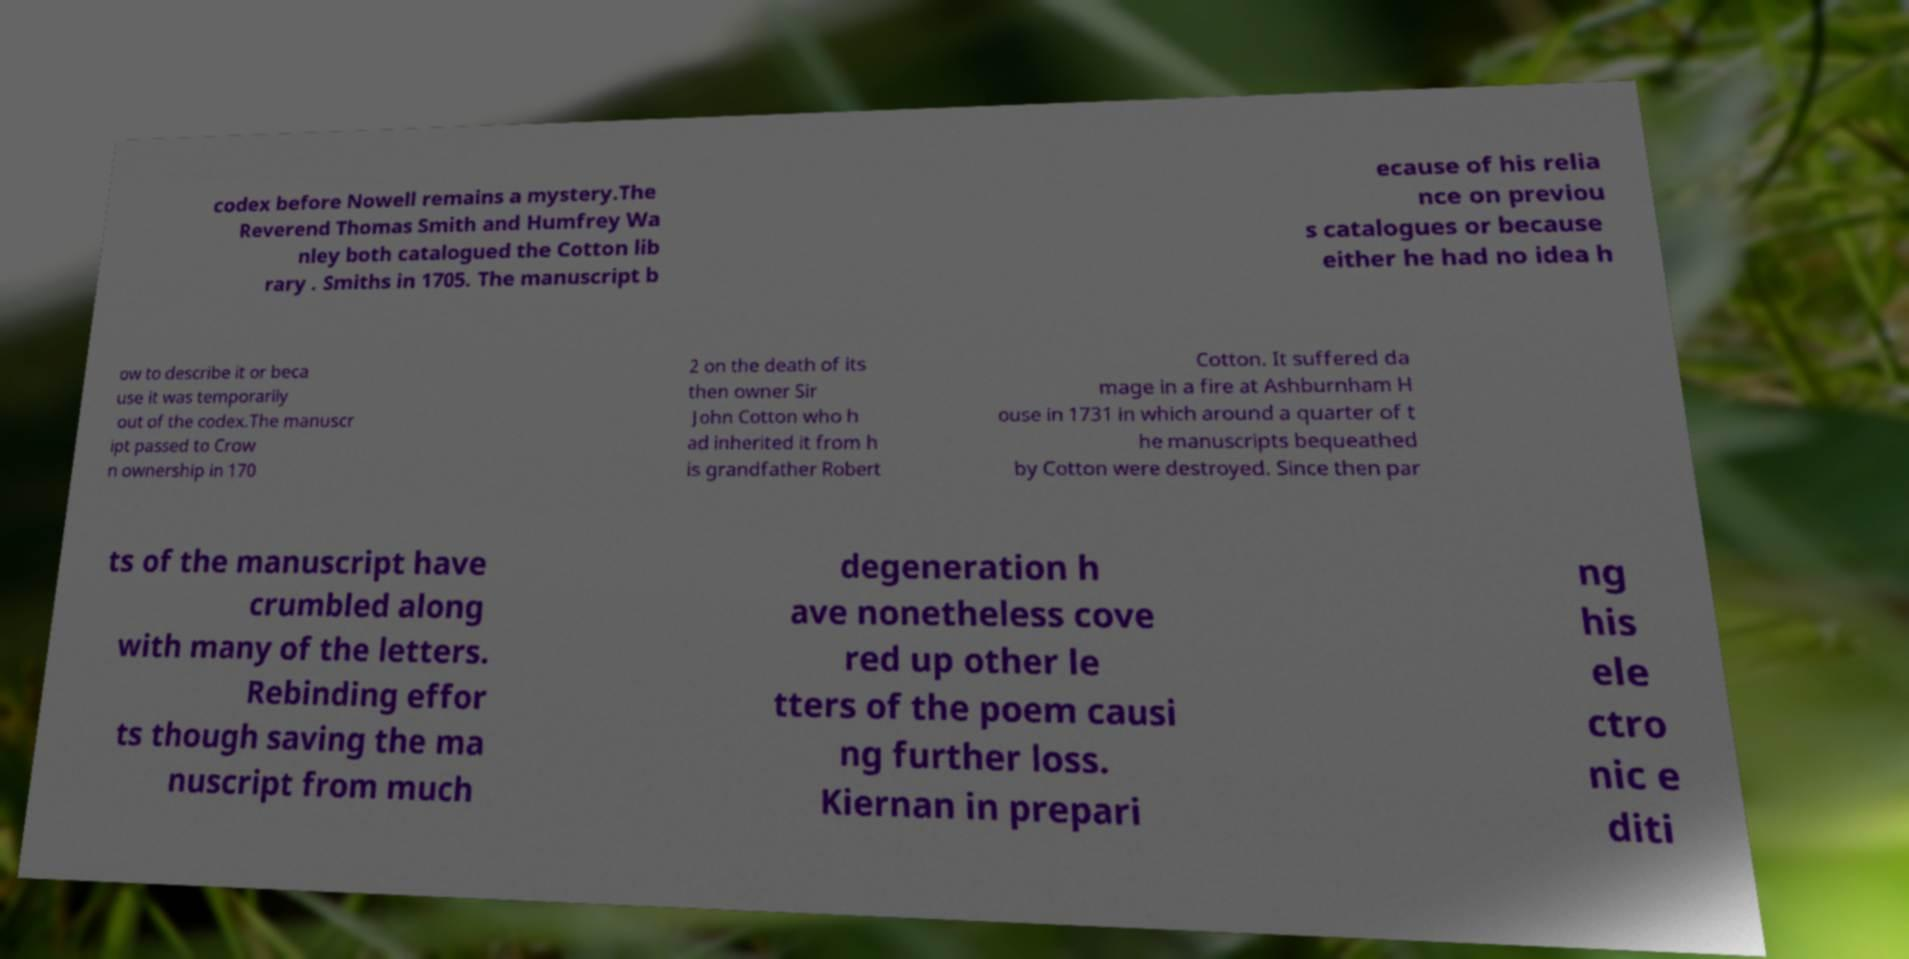Please read and relay the text visible in this image. What does it say? codex before Nowell remains a mystery.The Reverend Thomas Smith and Humfrey Wa nley both catalogued the Cotton lib rary . Smiths in 1705. The manuscript b ecause of his relia nce on previou s catalogues or because either he had no idea h ow to describe it or beca use it was temporarily out of the codex.The manuscr ipt passed to Crow n ownership in 170 2 on the death of its then owner Sir John Cotton who h ad inherited it from h is grandfather Robert Cotton. It suffered da mage in a fire at Ashburnham H ouse in 1731 in which around a quarter of t he manuscripts bequeathed by Cotton were destroyed. Since then par ts of the manuscript have crumbled along with many of the letters. Rebinding effor ts though saving the ma nuscript from much degeneration h ave nonetheless cove red up other le tters of the poem causi ng further loss. Kiernan in prepari ng his ele ctro nic e diti 